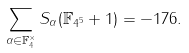<formula> <loc_0><loc_0><loc_500><loc_500>\sum _ { \alpha \in \mathbb { F } _ { 4 } ^ { \times } } S _ { \alpha } ( \mathbb { F } _ { 4 ^ { 5 } } + 1 ) = - 1 7 6 .</formula> 